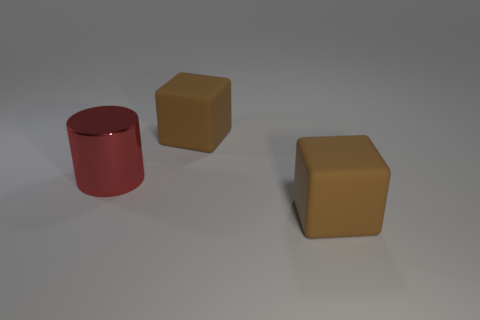Are there any other things that have the same shape as the red thing?
Provide a succinct answer. No. There is a large brown thing in front of the metallic object; is there a big brown thing that is to the left of it?
Make the answer very short. Yes. How many things are either large brown objects that are behind the large metal cylinder or brown things?
Your answer should be compact. 2. How many other objects are the same material as the cylinder?
Give a very brief answer. 0. How big is the brown rubber block behind the red thing?
Give a very brief answer. Large. Do the big red cylinder and the brown object behind the red object have the same material?
Provide a succinct answer. No. Do the brown rubber thing behind the red shiny cylinder and the large shiny object have the same shape?
Offer a very short reply. No. Do the big red thing and the large brown thing that is behind the large red shiny cylinder have the same shape?
Give a very brief answer. No. Is there a red metallic object?
Give a very brief answer. Yes. Is the number of large brown rubber cubes behind the red object the same as the number of red things?
Provide a short and direct response. Yes. 